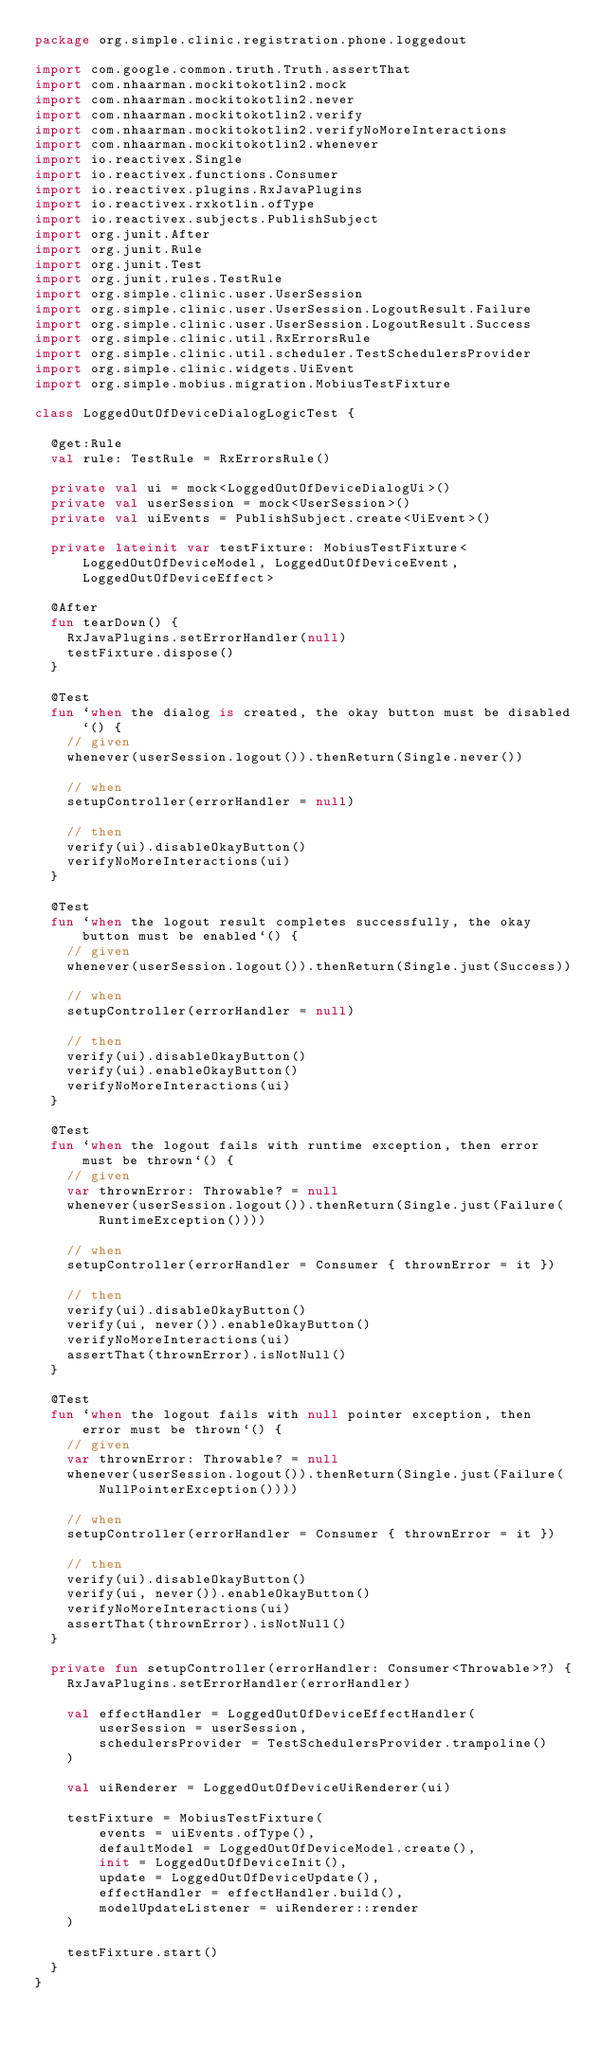<code> <loc_0><loc_0><loc_500><loc_500><_Kotlin_>package org.simple.clinic.registration.phone.loggedout

import com.google.common.truth.Truth.assertThat
import com.nhaarman.mockitokotlin2.mock
import com.nhaarman.mockitokotlin2.never
import com.nhaarman.mockitokotlin2.verify
import com.nhaarman.mockitokotlin2.verifyNoMoreInteractions
import com.nhaarman.mockitokotlin2.whenever
import io.reactivex.Single
import io.reactivex.functions.Consumer
import io.reactivex.plugins.RxJavaPlugins
import io.reactivex.rxkotlin.ofType
import io.reactivex.subjects.PublishSubject
import org.junit.After
import org.junit.Rule
import org.junit.Test
import org.junit.rules.TestRule
import org.simple.clinic.user.UserSession
import org.simple.clinic.user.UserSession.LogoutResult.Failure
import org.simple.clinic.user.UserSession.LogoutResult.Success
import org.simple.clinic.util.RxErrorsRule
import org.simple.clinic.util.scheduler.TestSchedulersProvider
import org.simple.clinic.widgets.UiEvent
import org.simple.mobius.migration.MobiusTestFixture

class LoggedOutOfDeviceDialogLogicTest {

  @get:Rule
  val rule: TestRule = RxErrorsRule()

  private val ui = mock<LoggedOutOfDeviceDialogUi>()
  private val userSession = mock<UserSession>()
  private val uiEvents = PublishSubject.create<UiEvent>()

  private lateinit var testFixture: MobiusTestFixture<LoggedOutOfDeviceModel, LoggedOutOfDeviceEvent, LoggedOutOfDeviceEffect>

  @After
  fun tearDown() {
    RxJavaPlugins.setErrorHandler(null)
    testFixture.dispose()
  }

  @Test
  fun `when the dialog is created, the okay button must be disabled`() {
    // given
    whenever(userSession.logout()).thenReturn(Single.never())

    // when
    setupController(errorHandler = null)

    // then
    verify(ui).disableOkayButton()
    verifyNoMoreInteractions(ui)
  }

  @Test
  fun `when the logout result completes successfully, the okay button must be enabled`() {
    // given
    whenever(userSession.logout()).thenReturn(Single.just(Success))

    // when
    setupController(errorHandler = null)

    // then
    verify(ui).disableOkayButton()
    verify(ui).enableOkayButton()
    verifyNoMoreInteractions(ui)
  }

  @Test
  fun `when the logout fails with runtime exception, then error must be thrown`() {
    // given
    var thrownError: Throwable? = null
    whenever(userSession.logout()).thenReturn(Single.just(Failure(RuntimeException())))

    // when
    setupController(errorHandler = Consumer { thrownError = it })

    // then
    verify(ui).disableOkayButton()
    verify(ui, never()).enableOkayButton()
    verifyNoMoreInteractions(ui)
    assertThat(thrownError).isNotNull()
  }

  @Test
  fun `when the logout fails with null pointer exception, then error must be thrown`() {
    // given
    var thrownError: Throwable? = null
    whenever(userSession.logout()).thenReturn(Single.just(Failure(NullPointerException())))

    // when
    setupController(errorHandler = Consumer { thrownError = it })

    // then
    verify(ui).disableOkayButton()
    verify(ui, never()).enableOkayButton()
    verifyNoMoreInteractions(ui)
    assertThat(thrownError).isNotNull()
  }

  private fun setupController(errorHandler: Consumer<Throwable>?) {
    RxJavaPlugins.setErrorHandler(errorHandler)

    val effectHandler = LoggedOutOfDeviceEffectHandler(
        userSession = userSession,
        schedulersProvider = TestSchedulersProvider.trampoline()
    )

    val uiRenderer = LoggedOutOfDeviceUiRenderer(ui)

    testFixture = MobiusTestFixture(
        events = uiEvents.ofType(),
        defaultModel = LoggedOutOfDeviceModel.create(),
        init = LoggedOutOfDeviceInit(),
        update = LoggedOutOfDeviceUpdate(),
        effectHandler = effectHandler.build(),
        modelUpdateListener = uiRenderer::render
    )

    testFixture.start()
  }
}
</code> 